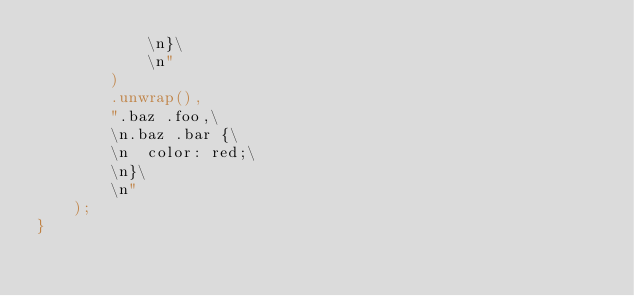<code> <loc_0><loc_0><loc_500><loc_500><_Rust_>            \n}\
            \n"
        )
        .unwrap(),
        ".baz .foo,\
        \n.baz .bar {\
        \n  color: red;\
        \n}\
        \n"
    );
}
</code> 